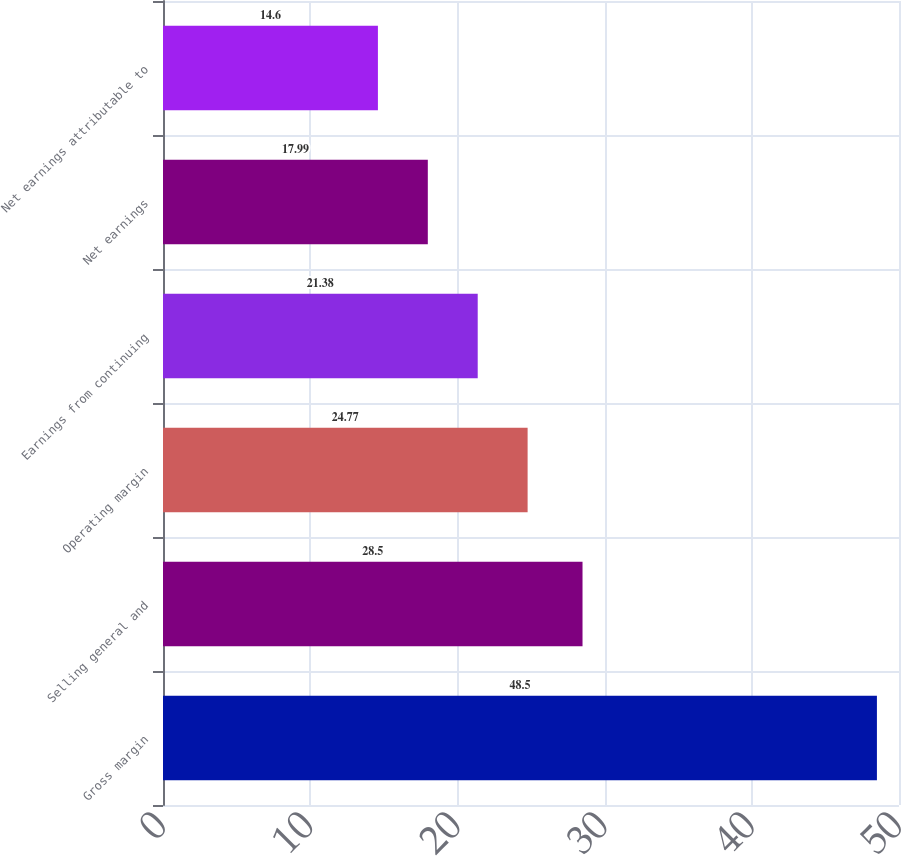Convert chart to OTSL. <chart><loc_0><loc_0><loc_500><loc_500><bar_chart><fcel>Gross margin<fcel>Selling general and<fcel>Operating margin<fcel>Earnings from continuing<fcel>Net earnings<fcel>Net earnings attributable to<nl><fcel>48.5<fcel>28.5<fcel>24.77<fcel>21.38<fcel>17.99<fcel>14.6<nl></chart> 